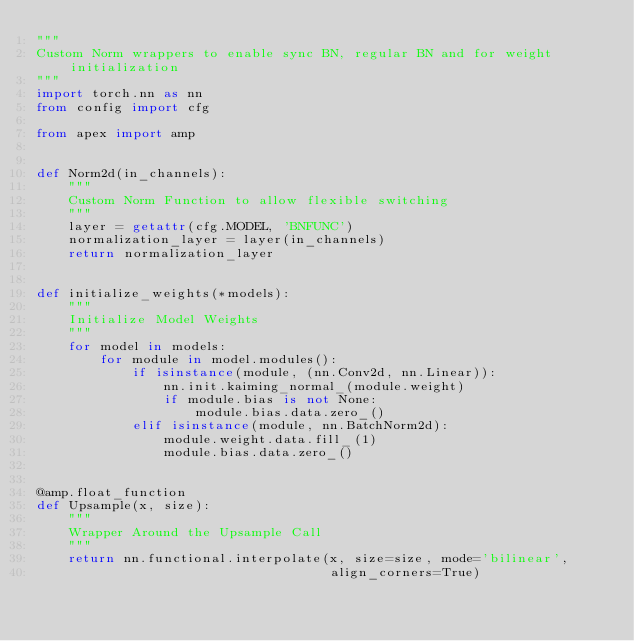Convert code to text. <code><loc_0><loc_0><loc_500><loc_500><_Python_>"""
Custom Norm wrappers to enable sync BN, regular BN and for weight initialization
"""
import torch.nn as nn
from config import cfg

from apex import amp


def Norm2d(in_channels):
    """
    Custom Norm Function to allow flexible switching
    """
    layer = getattr(cfg.MODEL, 'BNFUNC')
    normalization_layer = layer(in_channels)
    return normalization_layer


def initialize_weights(*models):
    """
    Initialize Model Weights
    """
    for model in models:
        for module in model.modules():
            if isinstance(module, (nn.Conv2d, nn.Linear)):
                nn.init.kaiming_normal_(module.weight)
                if module.bias is not None:
                    module.bias.data.zero_()
            elif isinstance(module, nn.BatchNorm2d):
                module.weight.data.fill_(1)
                module.bias.data.zero_()


@amp.float_function
def Upsample(x, size):
    """
    Wrapper Around the Upsample Call
    """
    return nn.functional.interpolate(x, size=size, mode='bilinear',
                                     align_corners=True)
</code> 